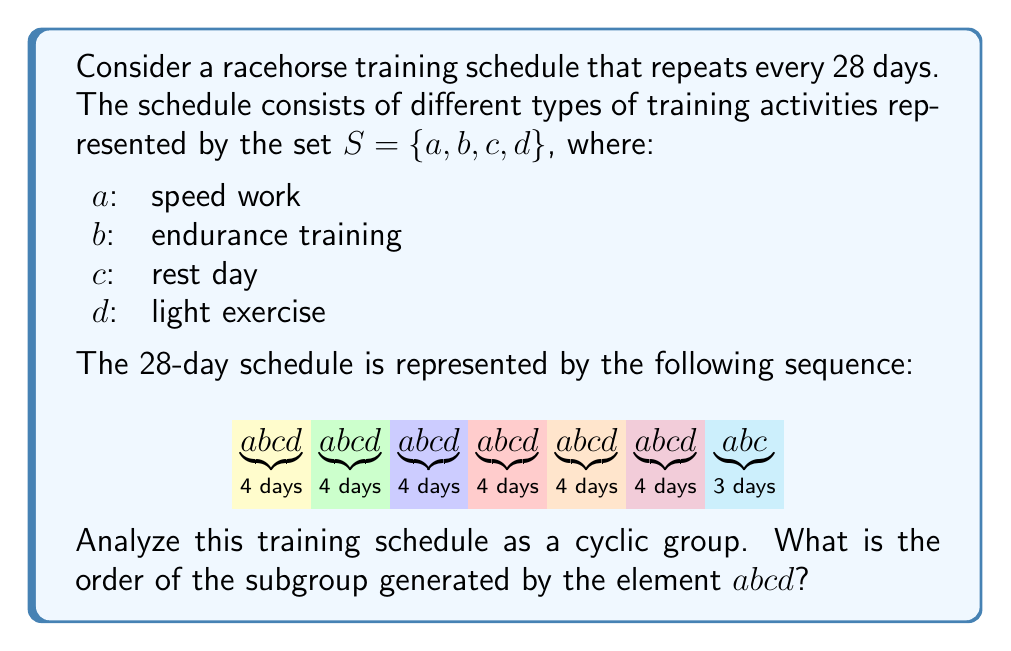Help me with this question. Let's approach this step-by-step:

1) First, we need to understand what the cyclic subgroup generated by $abcd$ means in this context. It represents how many times we need to repeat the sequence $abcd$ to get back to the starting point of the overall schedule.

2) The entire schedule is 28 days long, and can be seen as 7 repetitions of the sequence $abcd$.

3) In group theory terms, we can represent this as:
   $$(abcd)^7 = e$$
   where $e$ is the identity element (the entire 28-day cycle).

4) The order of an element in a group is the smallest positive integer $n$ such that $a^n = e$, where $a$ is the element and $e$ is the identity.

5) In this case, we can see that $(abcd)^7 = e$, and there is no smaller positive integer that satisfies this equation.

6) Therefore, the order of the subgroup generated by $abcd$ is 7.

This means that after 7 repetitions of the $abcd$ sequence (which is 28 days), the training schedule comes back to its starting point, forming a complete cycle.
Answer: 7 